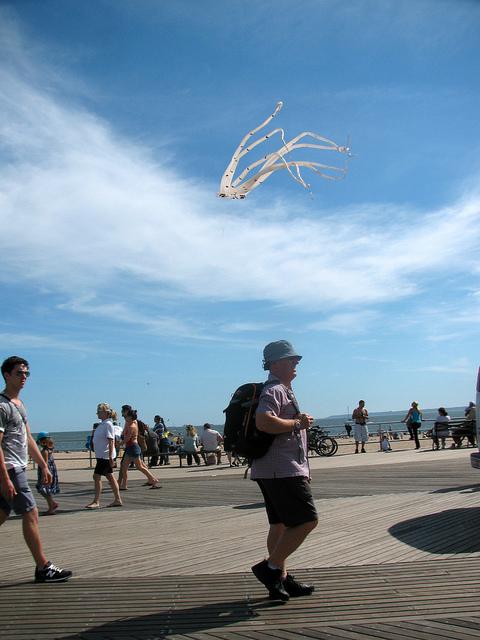How many kites are there?
Write a very short answer. 1. What style of hat is this person wearing?
Give a very brief answer. Bucket. What color shirt is the man in the center wearing?
Concise answer only. Gray. What is in the sky?
Answer briefly. Kite. Is this a skateboard park?
Quick response, please. No. What is this group of people doing?
Short answer required. Walking. 